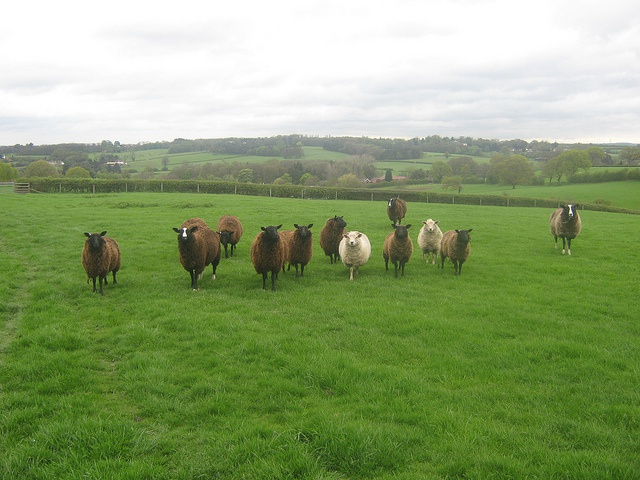Describe the objects in this image and their specific colors. I can see sheep in white, black, olive, and gray tones, sheep in white, black, olive, and gray tones, sheep in white, black, and darkgreen tones, sheep in white, darkgreen, black, and gray tones, and sheep in white, tan, olive, and beige tones in this image. 